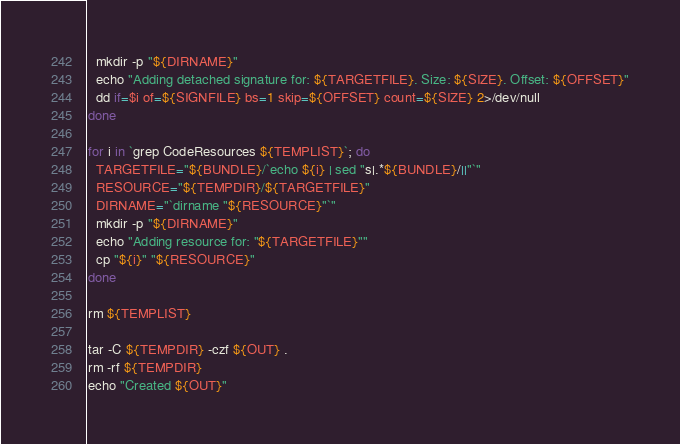Convert code to text. <code><loc_0><loc_0><loc_500><loc_500><_Bash_>  mkdir -p "${DIRNAME}"
  echo "Adding detached signature for: ${TARGETFILE}. Size: ${SIZE}. Offset: ${OFFSET}"
  dd if=$i of=${SIGNFILE} bs=1 skip=${OFFSET} count=${SIZE} 2>/dev/null
done

for i in `grep CodeResources ${TEMPLIST}`; do
  TARGETFILE="${BUNDLE}/`echo ${i} | sed "s|.*${BUNDLE}/||"`"
  RESOURCE="${TEMPDIR}/${TARGETFILE}"
  DIRNAME="`dirname "${RESOURCE}"`"
  mkdir -p "${DIRNAME}"
  echo "Adding resource for: "${TARGETFILE}""
  cp "${i}" "${RESOURCE}"
done

rm ${TEMPLIST}

tar -C ${TEMPDIR} -czf ${OUT} .
rm -rf ${TEMPDIR}
echo "Created ${OUT}"
</code> 